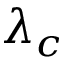Convert formula to latex. <formula><loc_0><loc_0><loc_500><loc_500>\lambda _ { c }</formula> 